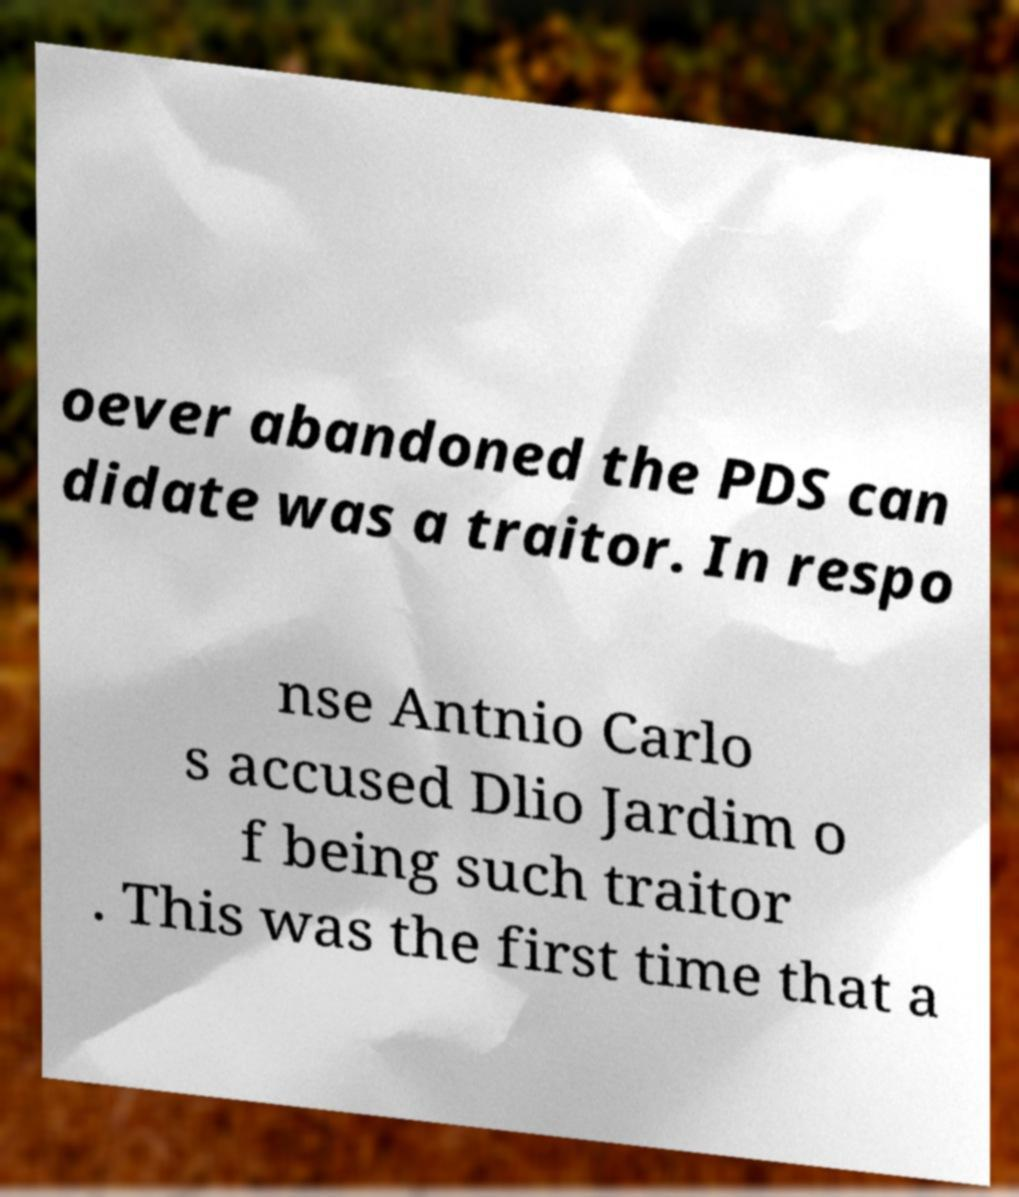Could you extract and type out the text from this image? oever abandoned the PDS can didate was a traitor. In respo nse Antnio Carlo s accused Dlio Jardim o f being such traitor . This was the first time that a 